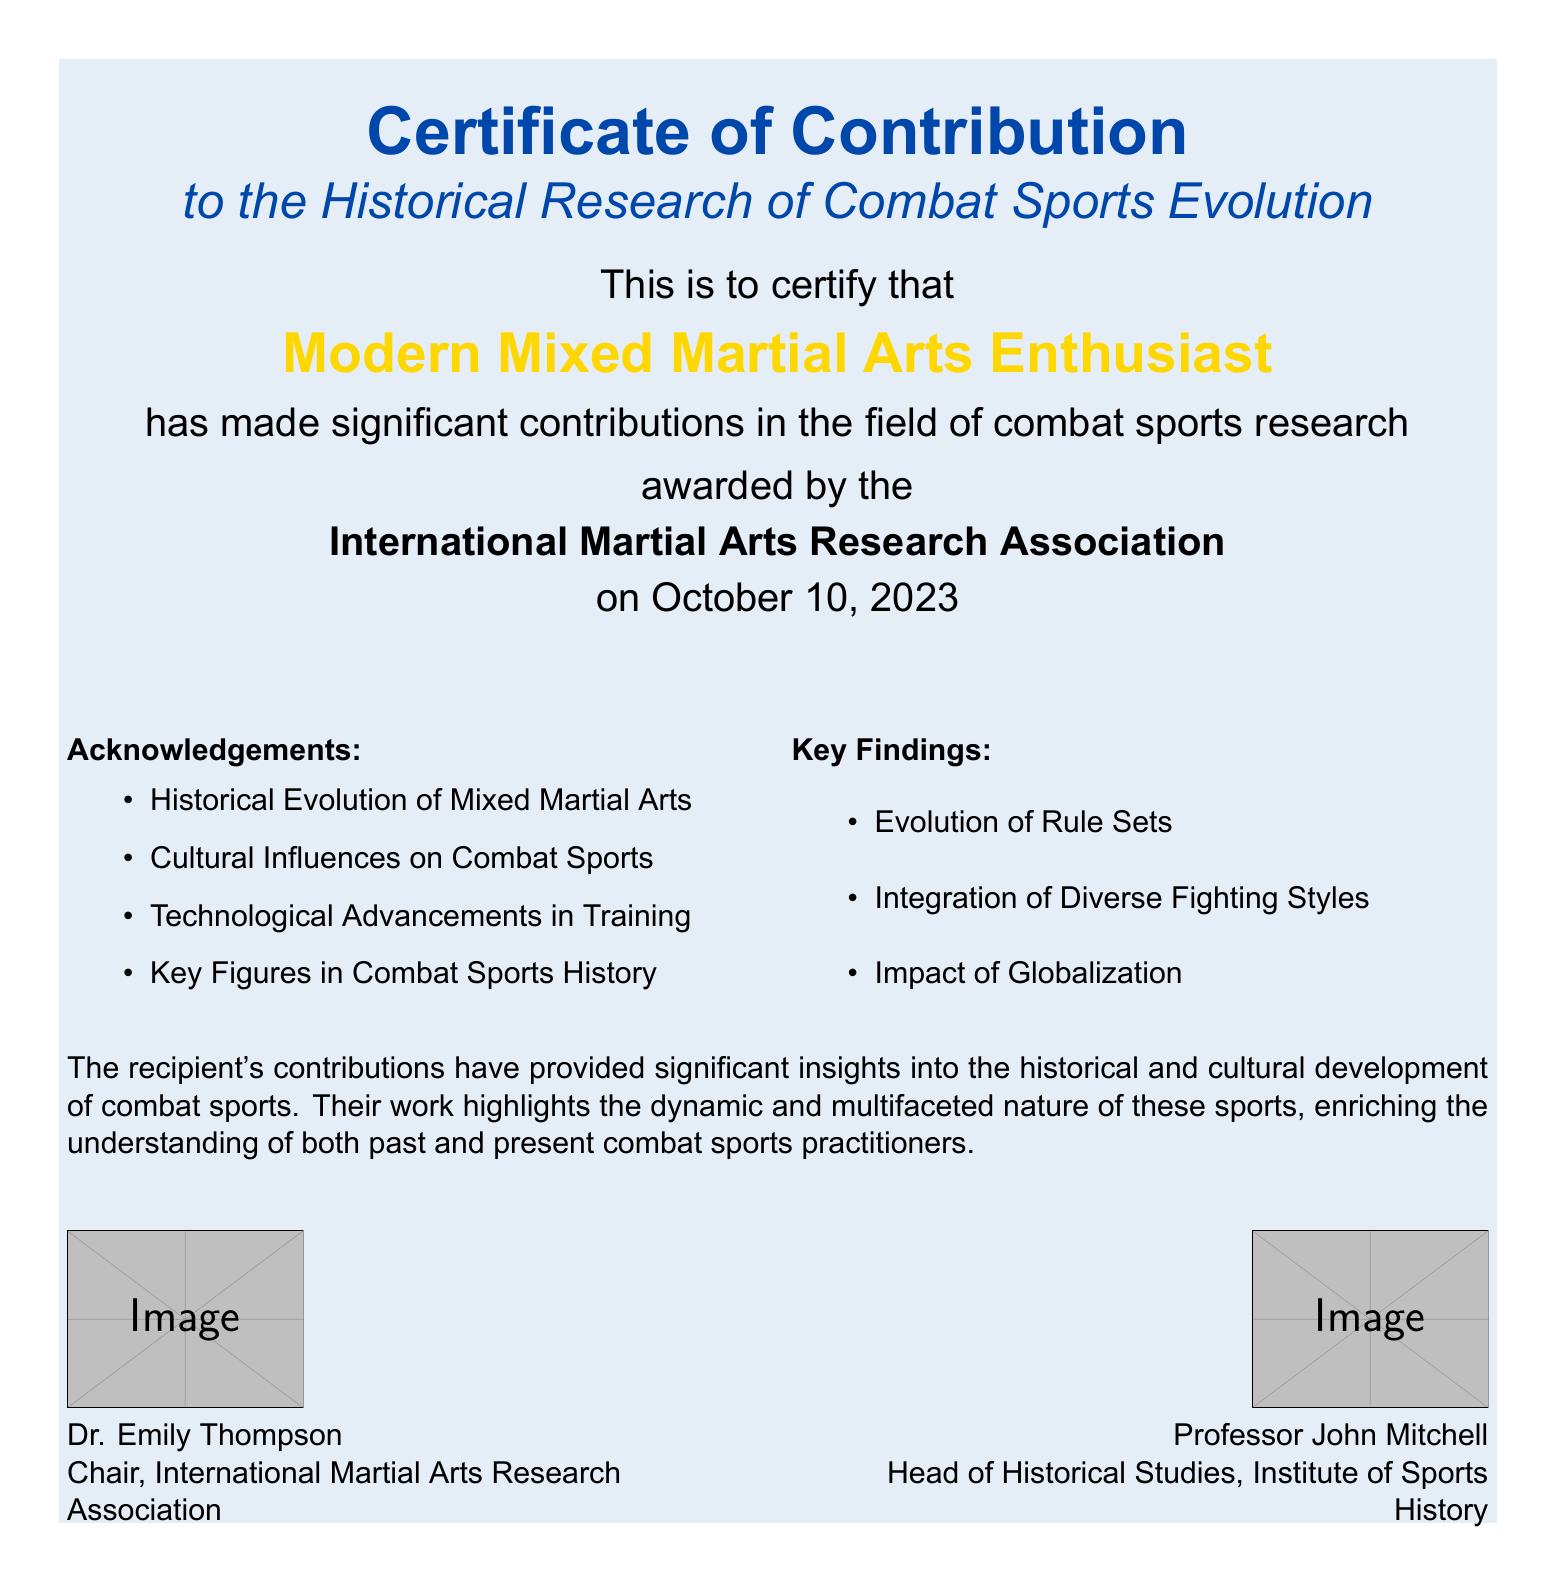What is the title of the certificate? The title of the certificate is found at the top of the document.
Answer: Certificate of Contribution Who is the recipient of the certificate? The recipient is indicated in the middle of the document.
Answer: Modern Mixed Martial Arts Enthusiast What organization awarded the certificate? The awarding organization is mentioned just before the date.
Answer: International Martial Arts Research Association When was the certificate awarded? The date of the award is specified at the bottom section of the document.
Answer: October 10, 2023 What is one of the acknowledgements listed on the certificate? Acknowledgements are provided in the document as a bullet list.
Answer: Historical Evolution of Mixed Martial Arts Name a key finding stated in the document. Key findings are listed, which highlight significant insights from the research.
Answer: Evolution of Rule Sets What color is used for the title on the certificate? The color of the title can be identified visually from the document.
Answer: Fighter blue Who is the chair of the awarding organization? The name and title of the chair are found in the bottom section.
Answer: Dr. Emily Thompson What is highlighted as a major influence on combat sports? This information is deduced from the acknowledgment list.
Answer: Cultural Influences on Combat Sports 